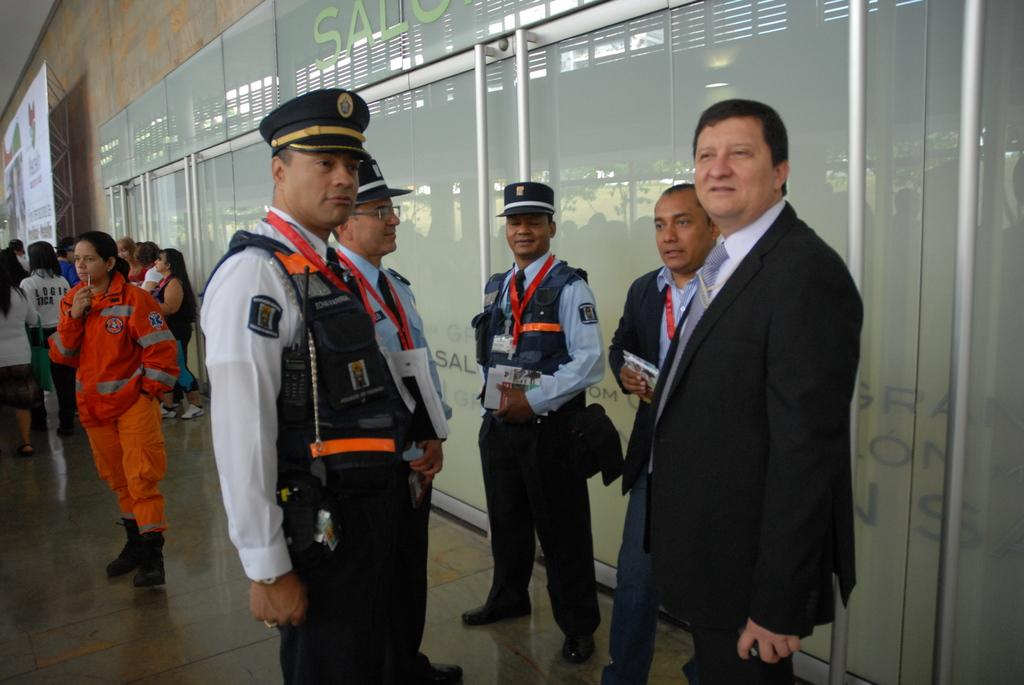How many people are in the image? There is a group of people in the image, but the exact number is not specified. What are some of the people wearing? Some of the people are wearing caps and jackets. What can be seen in the background of the image? There is a banner, a wall, and rods in the background of the image. What type of treatment is being administered to the people in the image? There is no indication in the image that any treatment is being administered to the people. What kind of growth can be observed on the rods in the background? There is no growth visible on the rods in the background; they appear to be plain rods. 